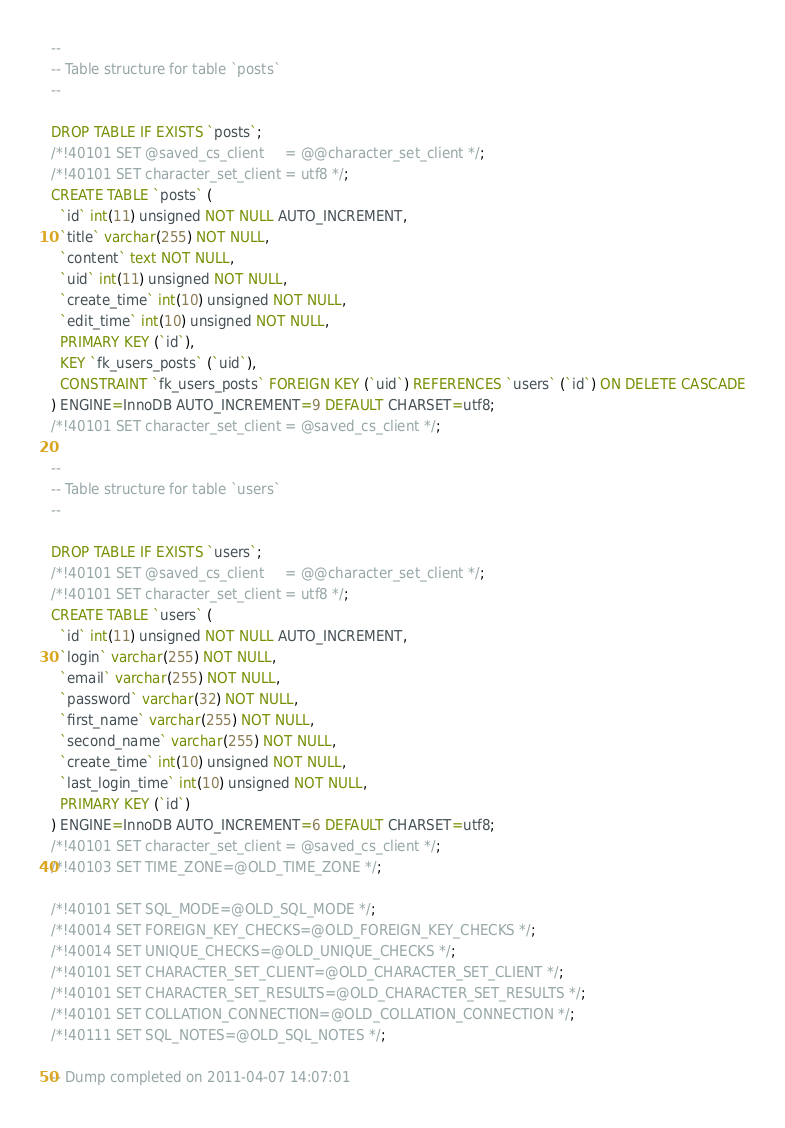<code> <loc_0><loc_0><loc_500><loc_500><_SQL_>
--
-- Table structure for table `posts`
--

DROP TABLE IF EXISTS `posts`;
/*!40101 SET @saved_cs_client     = @@character_set_client */;
/*!40101 SET character_set_client = utf8 */;
CREATE TABLE `posts` (
  `id` int(11) unsigned NOT NULL AUTO_INCREMENT,
  `title` varchar(255) NOT NULL,
  `content` text NOT NULL,
  `uid` int(11) unsigned NOT NULL,
  `create_time` int(10) unsigned NOT NULL,
  `edit_time` int(10) unsigned NOT NULL,
  PRIMARY KEY (`id`),
  KEY `fk_users_posts` (`uid`),
  CONSTRAINT `fk_users_posts` FOREIGN KEY (`uid`) REFERENCES `users` (`id`) ON DELETE CASCADE
) ENGINE=InnoDB AUTO_INCREMENT=9 DEFAULT CHARSET=utf8;
/*!40101 SET character_set_client = @saved_cs_client */;

--
-- Table structure for table `users`
--

DROP TABLE IF EXISTS `users`;
/*!40101 SET @saved_cs_client     = @@character_set_client */;
/*!40101 SET character_set_client = utf8 */;
CREATE TABLE `users` (
  `id` int(11) unsigned NOT NULL AUTO_INCREMENT,
  `login` varchar(255) NOT NULL,
  `email` varchar(255) NOT NULL,
  `password` varchar(32) NOT NULL,
  `first_name` varchar(255) NOT NULL,
  `second_name` varchar(255) NOT NULL,
  `create_time` int(10) unsigned NOT NULL,
  `last_login_time` int(10) unsigned NOT NULL,
  PRIMARY KEY (`id`)
) ENGINE=InnoDB AUTO_INCREMENT=6 DEFAULT CHARSET=utf8;
/*!40101 SET character_set_client = @saved_cs_client */;
/*!40103 SET TIME_ZONE=@OLD_TIME_ZONE */;

/*!40101 SET SQL_MODE=@OLD_SQL_MODE */;
/*!40014 SET FOREIGN_KEY_CHECKS=@OLD_FOREIGN_KEY_CHECKS */;
/*!40014 SET UNIQUE_CHECKS=@OLD_UNIQUE_CHECKS */;
/*!40101 SET CHARACTER_SET_CLIENT=@OLD_CHARACTER_SET_CLIENT */;
/*!40101 SET CHARACTER_SET_RESULTS=@OLD_CHARACTER_SET_RESULTS */;
/*!40101 SET COLLATION_CONNECTION=@OLD_COLLATION_CONNECTION */;
/*!40111 SET SQL_NOTES=@OLD_SQL_NOTES */;

-- Dump completed on 2011-04-07 14:07:01
</code> 